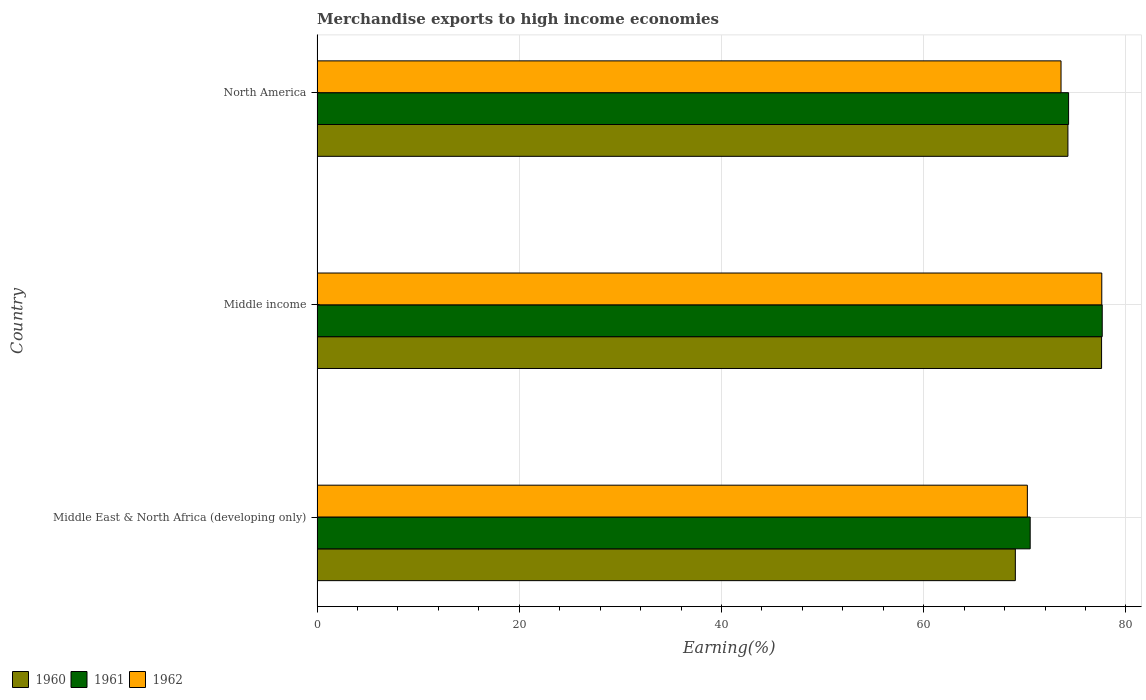How many groups of bars are there?
Your answer should be very brief. 3. Are the number of bars on each tick of the Y-axis equal?
Your response must be concise. Yes. How many bars are there on the 3rd tick from the bottom?
Offer a very short reply. 3. What is the label of the 3rd group of bars from the top?
Offer a terse response. Middle East & North Africa (developing only). In how many cases, is the number of bars for a given country not equal to the number of legend labels?
Ensure brevity in your answer.  0. What is the percentage of amount earned from merchandise exports in 1961 in Middle income?
Keep it short and to the point. 77.66. Across all countries, what is the maximum percentage of amount earned from merchandise exports in 1960?
Your answer should be compact. 77.59. Across all countries, what is the minimum percentage of amount earned from merchandise exports in 1961?
Your answer should be compact. 70.53. In which country was the percentage of amount earned from merchandise exports in 1961 maximum?
Your response must be concise. Middle income. In which country was the percentage of amount earned from merchandise exports in 1960 minimum?
Provide a short and direct response. Middle East & North Africa (developing only). What is the total percentage of amount earned from merchandise exports in 1960 in the graph?
Provide a short and direct response. 220.92. What is the difference between the percentage of amount earned from merchandise exports in 1961 in Middle income and that in North America?
Make the answer very short. 3.33. What is the difference between the percentage of amount earned from merchandise exports in 1962 in Middle income and the percentage of amount earned from merchandise exports in 1961 in North America?
Ensure brevity in your answer.  3.28. What is the average percentage of amount earned from merchandise exports in 1960 per country?
Your response must be concise. 73.64. What is the difference between the percentage of amount earned from merchandise exports in 1962 and percentage of amount earned from merchandise exports in 1960 in North America?
Offer a very short reply. -0.68. What is the ratio of the percentage of amount earned from merchandise exports in 1960 in Middle East & North Africa (developing only) to that in Middle income?
Offer a terse response. 0.89. Is the difference between the percentage of amount earned from merchandise exports in 1962 in Middle income and North America greater than the difference between the percentage of amount earned from merchandise exports in 1960 in Middle income and North America?
Keep it short and to the point. Yes. What is the difference between the highest and the second highest percentage of amount earned from merchandise exports in 1960?
Ensure brevity in your answer.  3.33. What is the difference between the highest and the lowest percentage of amount earned from merchandise exports in 1961?
Your answer should be compact. 7.13. In how many countries, is the percentage of amount earned from merchandise exports in 1962 greater than the average percentage of amount earned from merchandise exports in 1962 taken over all countries?
Give a very brief answer. 1. What does the 1st bar from the top in North America represents?
Offer a terse response. 1962. Is it the case that in every country, the sum of the percentage of amount earned from merchandise exports in 1962 and percentage of amount earned from merchandise exports in 1960 is greater than the percentage of amount earned from merchandise exports in 1961?
Ensure brevity in your answer.  Yes. Are all the bars in the graph horizontal?
Your answer should be very brief. Yes. How many countries are there in the graph?
Provide a short and direct response. 3. Are the values on the major ticks of X-axis written in scientific E-notation?
Keep it short and to the point. No. Where does the legend appear in the graph?
Offer a very short reply. Bottom left. What is the title of the graph?
Provide a short and direct response. Merchandise exports to high income economies. Does "2000" appear as one of the legend labels in the graph?
Offer a terse response. No. What is the label or title of the X-axis?
Your answer should be compact. Earning(%). What is the Earning(%) in 1960 in Middle East & North Africa (developing only)?
Keep it short and to the point. 69.06. What is the Earning(%) of 1961 in Middle East & North Africa (developing only)?
Offer a very short reply. 70.53. What is the Earning(%) in 1962 in Middle East & North Africa (developing only)?
Your response must be concise. 70.25. What is the Earning(%) of 1960 in Middle income?
Give a very brief answer. 77.59. What is the Earning(%) of 1961 in Middle income?
Provide a succinct answer. 77.66. What is the Earning(%) of 1962 in Middle income?
Keep it short and to the point. 77.61. What is the Earning(%) in 1960 in North America?
Offer a terse response. 74.27. What is the Earning(%) of 1961 in North America?
Provide a succinct answer. 74.33. What is the Earning(%) of 1962 in North America?
Make the answer very short. 73.58. Across all countries, what is the maximum Earning(%) of 1960?
Give a very brief answer. 77.59. Across all countries, what is the maximum Earning(%) in 1961?
Provide a short and direct response. 77.66. Across all countries, what is the maximum Earning(%) in 1962?
Your answer should be compact. 77.61. Across all countries, what is the minimum Earning(%) of 1960?
Ensure brevity in your answer.  69.06. Across all countries, what is the minimum Earning(%) in 1961?
Ensure brevity in your answer.  70.53. Across all countries, what is the minimum Earning(%) of 1962?
Your answer should be very brief. 70.25. What is the total Earning(%) of 1960 in the graph?
Provide a succinct answer. 220.92. What is the total Earning(%) in 1961 in the graph?
Offer a terse response. 222.52. What is the total Earning(%) of 1962 in the graph?
Your answer should be very brief. 221.45. What is the difference between the Earning(%) in 1960 in Middle East & North Africa (developing only) and that in Middle income?
Offer a very short reply. -8.53. What is the difference between the Earning(%) of 1961 in Middle East & North Africa (developing only) and that in Middle income?
Your answer should be very brief. -7.13. What is the difference between the Earning(%) of 1962 in Middle East & North Africa (developing only) and that in Middle income?
Keep it short and to the point. -7.36. What is the difference between the Earning(%) in 1960 in Middle East & North Africa (developing only) and that in North America?
Ensure brevity in your answer.  -5.2. What is the difference between the Earning(%) of 1961 in Middle East & North Africa (developing only) and that in North America?
Your answer should be compact. -3.8. What is the difference between the Earning(%) of 1962 in Middle East & North Africa (developing only) and that in North America?
Give a very brief answer. -3.33. What is the difference between the Earning(%) of 1960 in Middle income and that in North America?
Provide a short and direct response. 3.33. What is the difference between the Earning(%) in 1961 in Middle income and that in North America?
Give a very brief answer. 3.33. What is the difference between the Earning(%) in 1962 in Middle income and that in North America?
Provide a succinct answer. 4.03. What is the difference between the Earning(%) of 1960 in Middle East & North Africa (developing only) and the Earning(%) of 1961 in Middle income?
Make the answer very short. -8.59. What is the difference between the Earning(%) in 1960 in Middle East & North Africa (developing only) and the Earning(%) in 1962 in Middle income?
Give a very brief answer. -8.55. What is the difference between the Earning(%) of 1961 in Middle East & North Africa (developing only) and the Earning(%) of 1962 in Middle income?
Make the answer very short. -7.08. What is the difference between the Earning(%) of 1960 in Middle East & North Africa (developing only) and the Earning(%) of 1961 in North America?
Ensure brevity in your answer.  -5.27. What is the difference between the Earning(%) of 1960 in Middle East & North Africa (developing only) and the Earning(%) of 1962 in North America?
Make the answer very short. -4.52. What is the difference between the Earning(%) in 1961 in Middle East & North Africa (developing only) and the Earning(%) in 1962 in North America?
Provide a succinct answer. -3.05. What is the difference between the Earning(%) in 1960 in Middle income and the Earning(%) in 1961 in North America?
Your response must be concise. 3.26. What is the difference between the Earning(%) of 1960 in Middle income and the Earning(%) of 1962 in North America?
Offer a terse response. 4.01. What is the difference between the Earning(%) in 1961 in Middle income and the Earning(%) in 1962 in North America?
Offer a very short reply. 4.07. What is the average Earning(%) in 1960 per country?
Your response must be concise. 73.64. What is the average Earning(%) of 1961 per country?
Keep it short and to the point. 74.17. What is the average Earning(%) in 1962 per country?
Offer a terse response. 73.82. What is the difference between the Earning(%) of 1960 and Earning(%) of 1961 in Middle East & North Africa (developing only)?
Your answer should be very brief. -1.47. What is the difference between the Earning(%) in 1960 and Earning(%) in 1962 in Middle East & North Africa (developing only)?
Make the answer very short. -1.19. What is the difference between the Earning(%) in 1961 and Earning(%) in 1962 in Middle East & North Africa (developing only)?
Your answer should be compact. 0.28. What is the difference between the Earning(%) of 1960 and Earning(%) of 1961 in Middle income?
Provide a succinct answer. -0.07. What is the difference between the Earning(%) of 1960 and Earning(%) of 1962 in Middle income?
Offer a very short reply. -0.02. What is the difference between the Earning(%) in 1961 and Earning(%) in 1962 in Middle income?
Keep it short and to the point. 0.04. What is the difference between the Earning(%) of 1960 and Earning(%) of 1961 in North America?
Offer a very short reply. -0.07. What is the difference between the Earning(%) of 1960 and Earning(%) of 1962 in North America?
Your response must be concise. 0.68. What is the difference between the Earning(%) of 1961 and Earning(%) of 1962 in North America?
Keep it short and to the point. 0.75. What is the ratio of the Earning(%) of 1960 in Middle East & North Africa (developing only) to that in Middle income?
Offer a very short reply. 0.89. What is the ratio of the Earning(%) in 1961 in Middle East & North Africa (developing only) to that in Middle income?
Your response must be concise. 0.91. What is the ratio of the Earning(%) of 1962 in Middle East & North Africa (developing only) to that in Middle income?
Ensure brevity in your answer.  0.91. What is the ratio of the Earning(%) of 1961 in Middle East & North Africa (developing only) to that in North America?
Provide a succinct answer. 0.95. What is the ratio of the Earning(%) of 1962 in Middle East & North Africa (developing only) to that in North America?
Your answer should be very brief. 0.95. What is the ratio of the Earning(%) of 1960 in Middle income to that in North America?
Make the answer very short. 1.04. What is the ratio of the Earning(%) of 1961 in Middle income to that in North America?
Your answer should be compact. 1.04. What is the ratio of the Earning(%) of 1962 in Middle income to that in North America?
Offer a terse response. 1.05. What is the difference between the highest and the second highest Earning(%) in 1960?
Provide a succinct answer. 3.33. What is the difference between the highest and the second highest Earning(%) in 1961?
Provide a short and direct response. 3.33. What is the difference between the highest and the second highest Earning(%) in 1962?
Your response must be concise. 4.03. What is the difference between the highest and the lowest Earning(%) of 1960?
Your answer should be very brief. 8.53. What is the difference between the highest and the lowest Earning(%) of 1961?
Provide a short and direct response. 7.13. What is the difference between the highest and the lowest Earning(%) of 1962?
Ensure brevity in your answer.  7.36. 